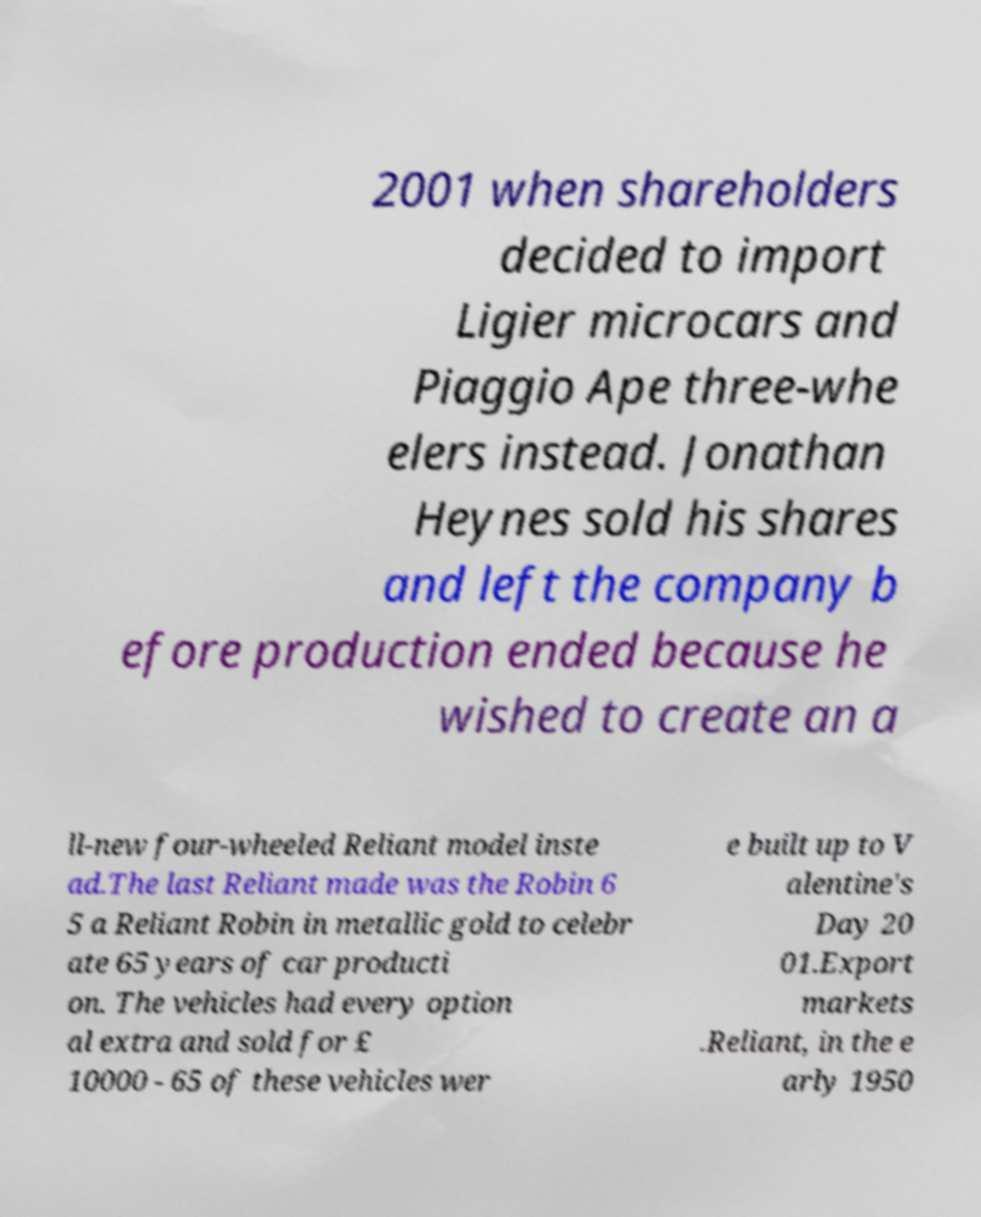Please identify and transcribe the text found in this image. 2001 when shareholders decided to import Ligier microcars and Piaggio Ape three-whe elers instead. Jonathan Heynes sold his shares and left the company b efore production ended because he wished to create an a ll-new four-wheeled Reliant model inste ad.The last Reliant made was the Robin 6 5 a Reliant Robin in metallic gold to celebr ate 65 years of car producti on. The vehicles had every option al extra and sold for £ 10000 - 65 of these vehicles wer e built up to V alentine's Day 20 01.Export markets .Reliant, in the e arly 1950 